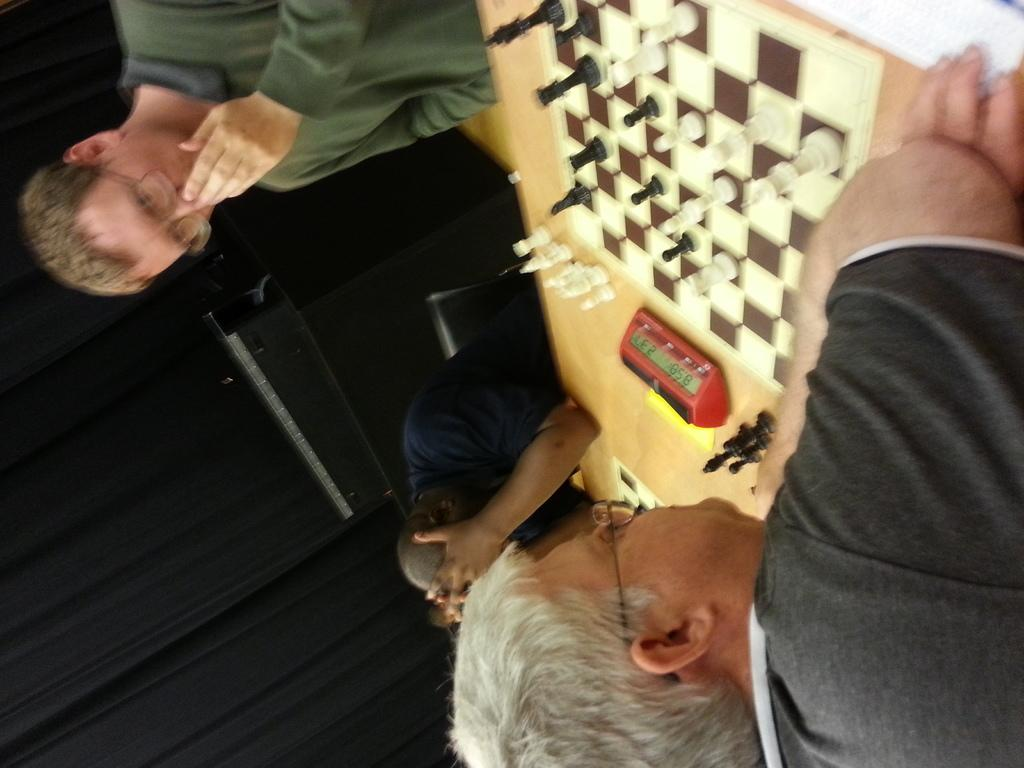What are the people in the image doing? The people in the image are sitting on chairs. What is on the table in the image? There are chess boards and chess pieces on the table. What else can be seen on the table? There is a clock on the table. What can be seen in the background of the image? There are curtains and a wall in the background. What type of debt is being discussed at the chess table in the image? There is no indication of any debt being discussed in the image; the focus is on the people playing chess and the items on the table. 